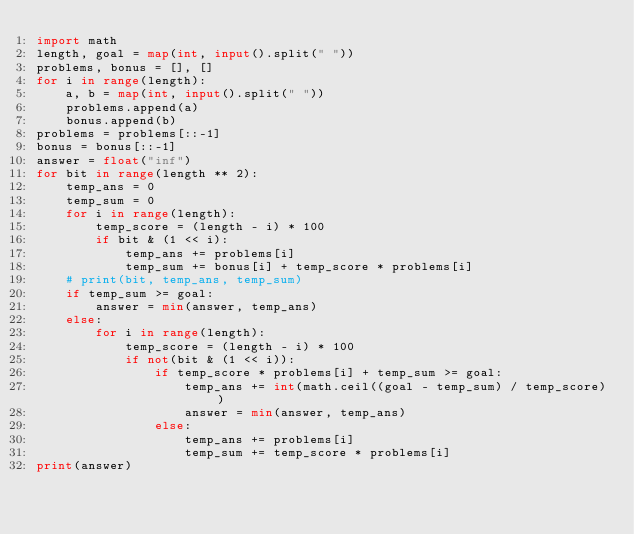<code> <loc_0><loc_0><loc_500><loc_500><_Python_>import math
length, goal = map(int, input().split(" "))
problems, bonus = [], []
for i in range(length):
    a, b = map(int, input().split(" "))
    problems.append(a)
    bonus.append(b)
problems = problems[::-1]
bonus = bonus[::-1]
answer = float("inf")
for bit in range(length ** 2):
    temp_ans = 0
    temp_sum = 0
    for i in range(length):
        temp_score = (length - i) * 100
        if bit & (1 << i):
            temp_ans += problems[i]
            temp_sum += bonus[i] + temp_score * problems[i]
    # print(bit, temp_ans, temp_sum)
    if temp_sum >= goal:
        answer = min(answer, temp_ans)
    else:
        for i in range(length):
            temp_score = (length - i) * 100
            if not(bit & (1 << i)):
                if temp_score * problems[i] + temp_sum >= goal:
                    temp_ans += int(math.ceil((goal - temp_sum) / temp_score))
                    answer = min(answer, temp_ans)
                else:
                    temp_ans += problems[i]
                    temp_sum += temp_score * problems[i]
print(answer)</code> 